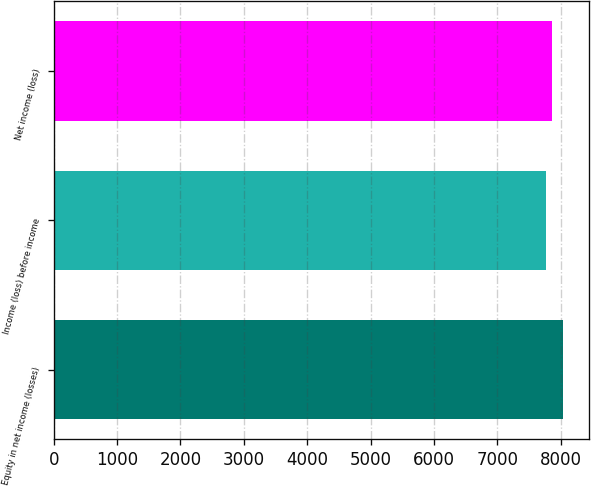Convert chart. <chart><loc_0><loc_0><loc_500><loc_500><bar_chart><fcel>Equity in net income (losses)<fcel>Income (loss) before income<fcel>Net income (loss)<nl><fcel>8040<fcel>7770<fcel>7864<nl></chart> 